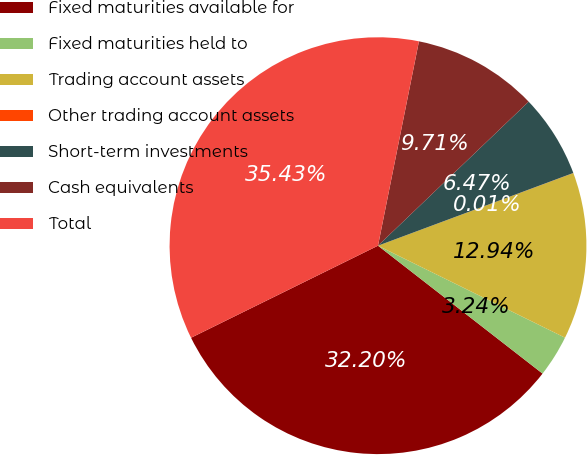<chart> <loc_0><loc_0><loc_500><loc_500><pie_chart><fcel>Fixed maturities available for<fcel>Fixed maturities held to<fcel>Trading account assets<fcel>Other trading account assets<fcel>Short-term investments<fcel>Cash equivalents<fcel>Total<nl><fcel>32.2%<fcel>3.24%<fcel>12.94%<fcel>0.01%<fcel>6.47%<fcel>9.71%<fcel>35.43%<nl></chart> 